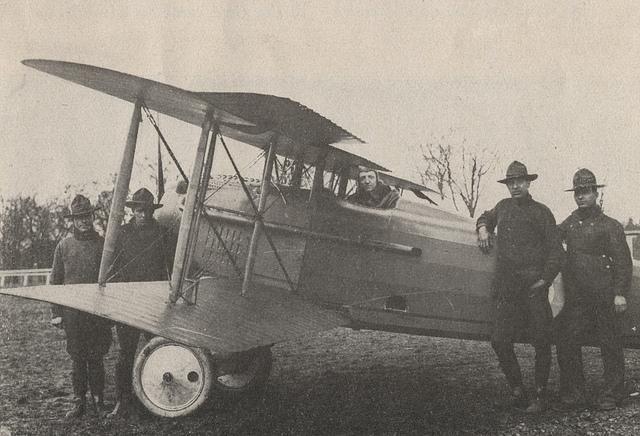How many men are in photo?
Give a very brief answer. 5. How many people can be seen?
Give a very brief answer. 4. How many airplanes are in the picture?
Give a very brief answer. 1. 